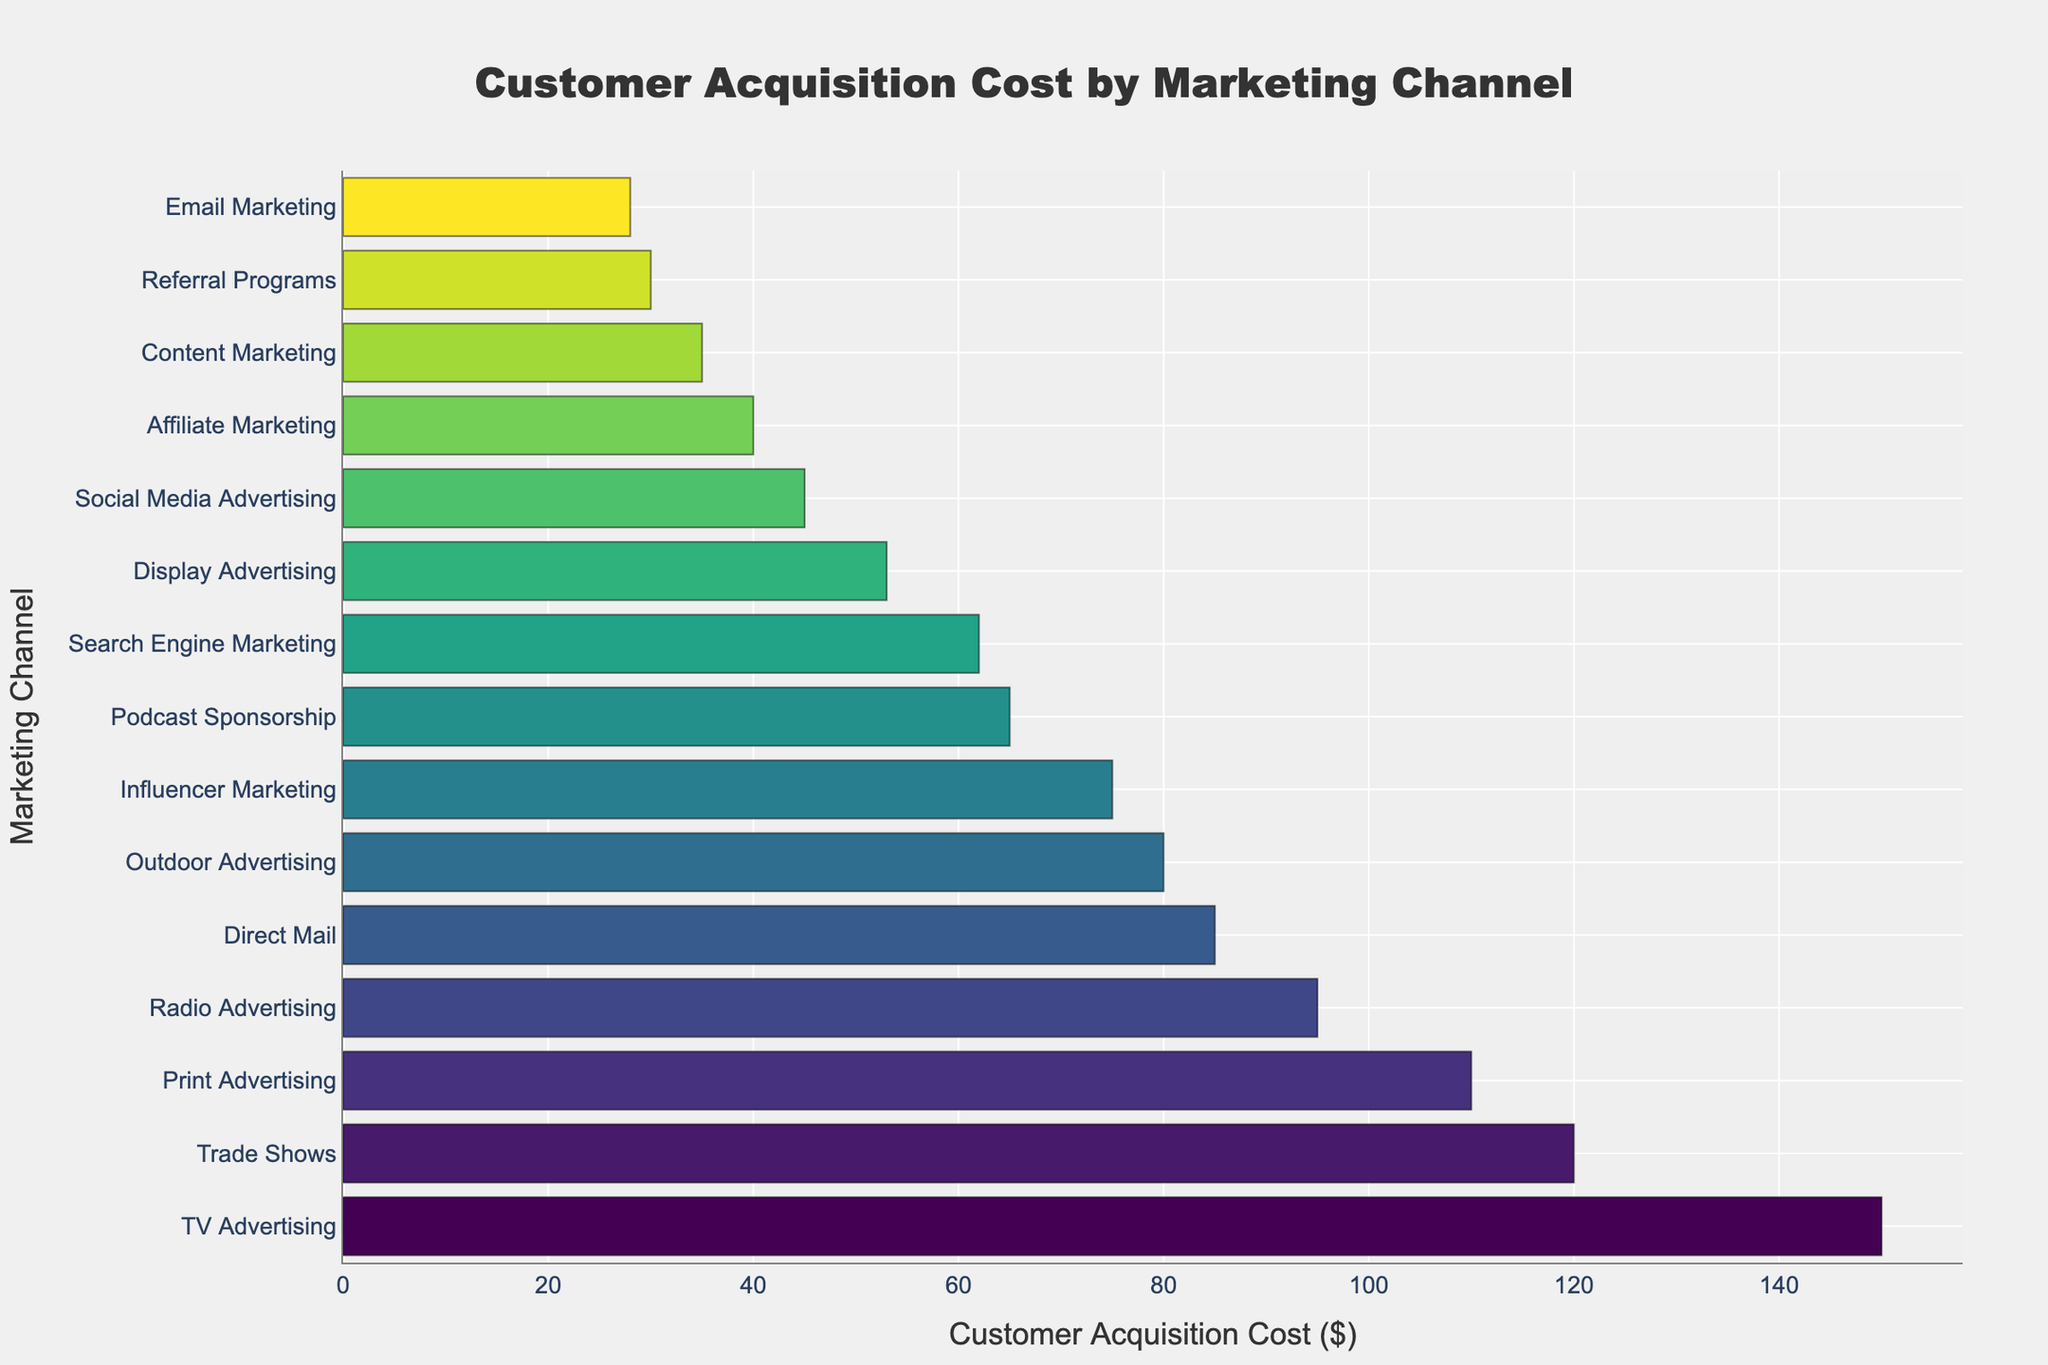What is the marketing channel with the highest customer acquisition cost? Identify the highest bar in the chart, which corresponds to the marketing channel with the highest cost. This bar's label indicates that TV Advertising has the highest customer acquisition cost.
Answer: TV Advertising Which two marketing channels have the lowest customer acquisition costs? Locate the two shortest bars in the chart. The labels on these bars indicate that Email Marketing and Referral Programs have the lowest customer acquisition costs.
Answer: Email Marketing and Referral Programs How much higher is the customer acquisition cost for TV Advertising compared to Social Media Advertising? Determine the lengths of the bars representing TV Advertising and Social Media Advertising. Subtract the cost of Social Media Advertising ($45) from the cost of TV Advertising ($150).
Answer: $105 What is the average customer acquisition cost for Social Media Advertising, Email Marketing, and Content Marketing? Add the customer acquisition costs for Social Media Advertising ($45), Email Marketing ($28), and Content Marketing ($35), then divide by the number of channels (3) to get the average.
Answer: $36 Which marketing channel has a higher customer acquisition cost: Podcast Sponsorship or Print Advertising? Compare the lengths of the bars for Podcast Sponsorship and Print Advertising. The bar for Print Advertising is longer, indicating a higher customer acquisition cost.
Answer: Print Advertising How many marketing channels have a customer acquisition cost of $50 or more? Count the bars that represent costs equal to or greater than $50. There are 8 such bars: Search Engine Marketing, Influencer Marketing, Display Advertising, Direct Mail, TV Advertising, Radio Advertising, Print Advertising, and Outdoor Advertising.
Answer: 8 What is the sum of customer acquisition costs for all broadcast media channels (TV, Radio, and Podcast Sponsorship)? Add the customer acquisition costs for TV Advertising ($150), Radio Advertising ($95), and Podcast Sponsorship ($65) to get the total.
Answer: $310 Which marketing channels have a customer acquisition cost exactly between Content Marketing and Outdoor Advertising? Identify the customer acquisition costs for Content Marketing ($35) and Outdoor Advertising ($80). Find the marketing channels with costs that fall between these two values. These are: Affiliate Marketing ($40), Referral Programs ($30), and Display Advertising ($53).
Answer: Affiliate Marketing and Display Advertising Is the customer acquisition cost for Direct Mail higher than for Radio Advertising? Compare the lengths of the bars for Direct Mail and Radio Advertising. The bar for Radio Advertising is longer, indicating a higher customer acquisition cost.
Answer: No 